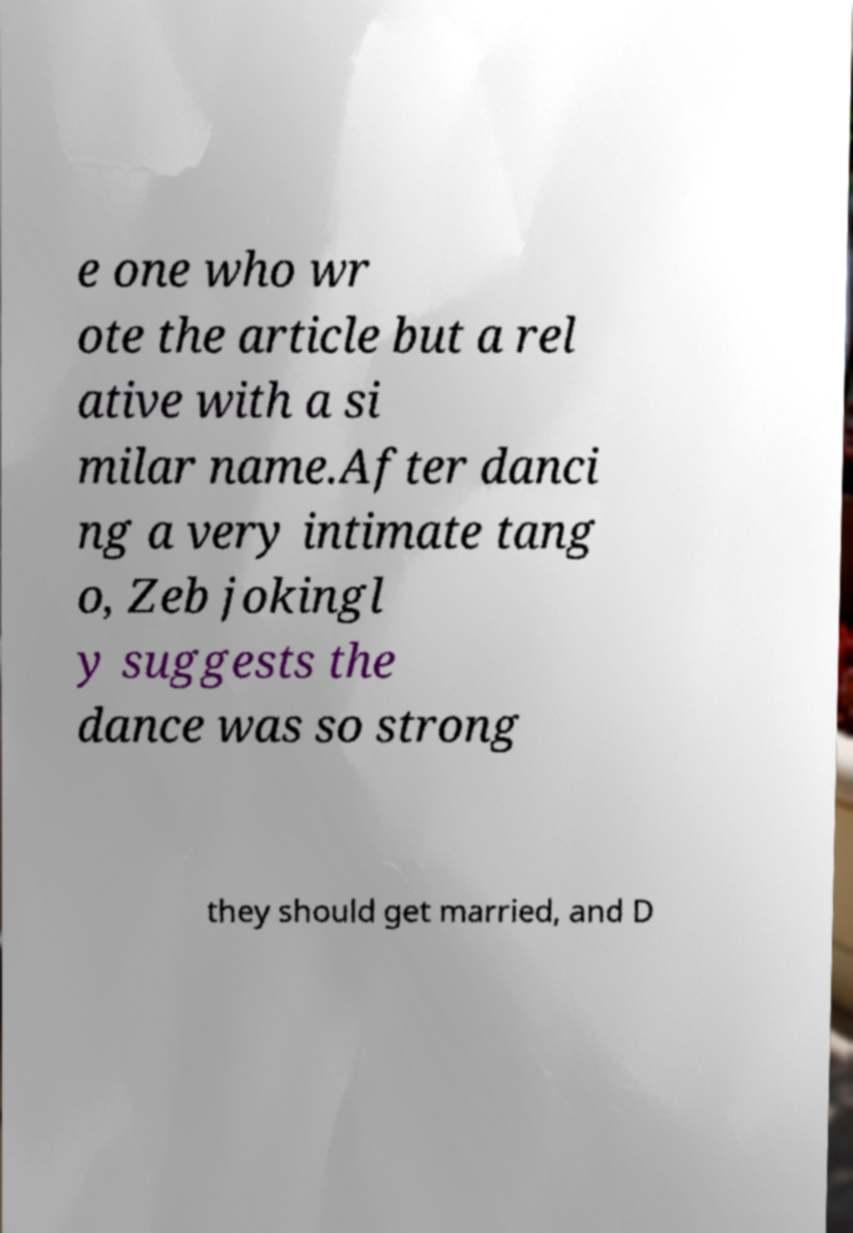Please read and relay the text visible in this image. What does it say? e one who wr ote the article but a rel ative with a si milar name.After danci ng a very intimate tang o, Zeb jokingl y suggests the dance was so strong they should get married, and D 